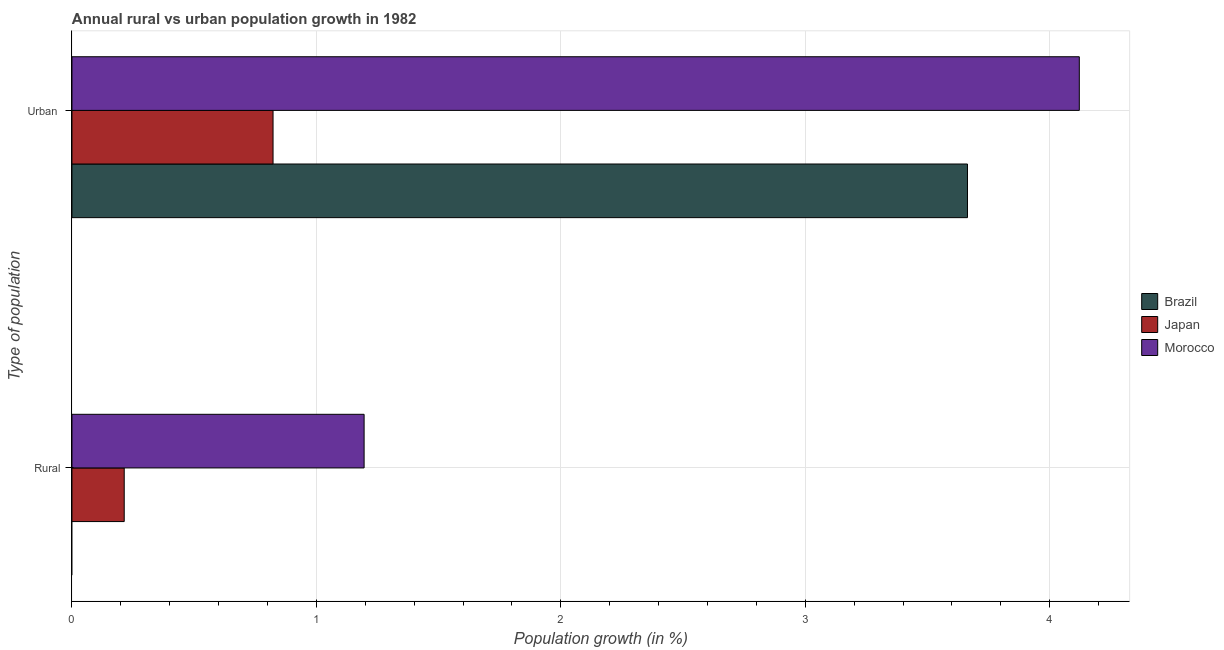How many groups of bars are there?
Your answer should be compact. 2. Are the number of bars per tick equal to the number of legend labels?
Offer a terse response. No. How many bars are there on the 1st tick from the top?
Keep it short and to the point. 3. What is the label of the 1st group of bars from the top?
Ensure brevity in your answer.  Urban . What is the rural population growth in Brazil?
Your answer should be compact. 0. Across all countries, what is the maximum urban population growth?
Your response must be concise. 4.12. Across all countries, what is the minimum urban population growth?
Provide a succinct answer. 0.82. In which country was the urban population growth maximum?
Make the answer very short. Morocco. What is the total rural population growth in the graph?
Make the answer very short. 1.41. What is the difference between the urban population growth in Brazil and that in Morocco?
Offer a terse response. -0.46. What is the difference between the rural population growth in Japan and the urban population growth in Morocco?
Provide a short and direct response. -3.91. What is the average urban population growth per country?
Offer a terse response. 2.87. What is the difference between the rural population growth and urban population growth in Morocco?
Offer a terse response. -2.93. In how many countries, is the urban population growth greater than 3.6 %?
Your answer should be very brief. 2. What is the ratio of the urban population growth in Morocco to that in Japan?
Your answer should be compact. 5.01. Are the values on the major ticks of X-axis written in scientific E-notation?
Keep it short and to the point. No. Does the graph contain any zero values?
Provide a succinct answer. Yes. Does the graph contain grids?
Offer a terse response. Yes. How many legend labels are there?
Provide a short and direct response. 3. What is the title of the graph?
Give a very brief answer. Annual rural vs urban population growth in 1982. What is the label or title of the X-axis?
Provide a succinct answer. Population growth (in %). What is the label or title of the Y-axis?
Ensure brevity in your answer.  Type of population. What is the Population growth (in %) of Japan in Rural?
Make the answer very short. 0.21. What is the Population growth (in %) in Morocco in Rural?
Keep it short and to the point. 1.2. What is the Population growth (in %) of Brazil in Urban ?
Your answer should be very brief. 3.66. What is the Population growth (in %) of Japan in Urban ?
Your answer should be compact. 0.82. What is the Population growth (in %) in Morocco in Urban ?
Offer a terse response. 4.12. Across all Type of population, what is the maximum Population growth (in %) in Brazil?
Ensure brevity in your answer.  3.66. Across all Type of population, what is the maximum Population growth (in %) of Japan?
Keep it short and to the point. 0.82. Across all Type of population, what is the maximum Population growth (in %) of Morocco?
Ensure brevity in your answer.  4.12. Across all Type of population, what is the minimum Population growth (in %) in Japan?
Your response must be concise. 0.21. Across all Type of population, what is the minimum Population growth (in %) in Morocco?
Your answer should be compact. 1.2. What is the total Population growth (in %) in Brazil in the graph?
Give a very brief answer. 3.66. What is the total Population growth (in %) of Japan in the graph?
Provide a succinct answer. 1.04. What is the total Population growth (in %) in Morocco in the graph?
Provide a succinct answer. 5.32. What is the difference between the Population growth (in %) in Japan in Rural and that in Urban ?
Give a very brief answer. -0.61. What is the difference between the Population growth (in %) in Morocco in Rural and that in Urban ?
Give a very brief answer. -2.93. What is the difference between the Population growth (in %) in Japan in Rural and the Population growth (in %) in Morocco in Urban ?
Provide a succinct answer. -3.91. What is the average Population growth (in %) of Brazil per Type of population?
Your answer should be compact. 1.83. What is the average Population growth (in %) of Japan per Type of population?
Give a very brief answer. 0.52. What is the average Population growth (in %) of Morocco per Type of population?
Offer a terse response. 2.66. What is the difference between the Population growth (in %) in Japan and Population growth (in %) in Morocco in Rural?
Your answer should be compact. -0.98. What is the difference between the Population growth (in %) in Brazil and Population growth (in %) in Japan in Urban ?
Your response must be concise. 2.84. What is the difference between the Population growth (in %) of Brazil and Population growth (in %) of Morocco in Urban ?
Provide a succinct answer. -0.46. What is the difference between the Population growth (in %) in Japan and Population growth (in %) in Morocco in Urban ?
Make the answer very short. -3.3. What is the ratio of the Population growth (in %) in Japan in Rural to that in Urban ?
Give a very brief answer. 0.26. What is the ratio of the Population growth (in %) in Morocco in Rural to that in Urban ?
Offer a terse response. 0.29. What is the difference between the highest and the second highest Population growth (in %) of Japan?
Provide a short and direct response. 0.61. What is the difference between the highest and the second highest Population growth (in %) in Morocco?
Offer a terse response. 2.93. What is the difference between the highest and the lowest Population growth (in %) in Brazil?
Offer a very short reply. 3.66. What is the difference between the highest and the lowest Population growth (in %) of Japan?
Keep it short and to the point. 0.61. What is the difference between the highest and the lowest Population growth (in %) of Morocco?
Provide a succinct answer. 2.93. 